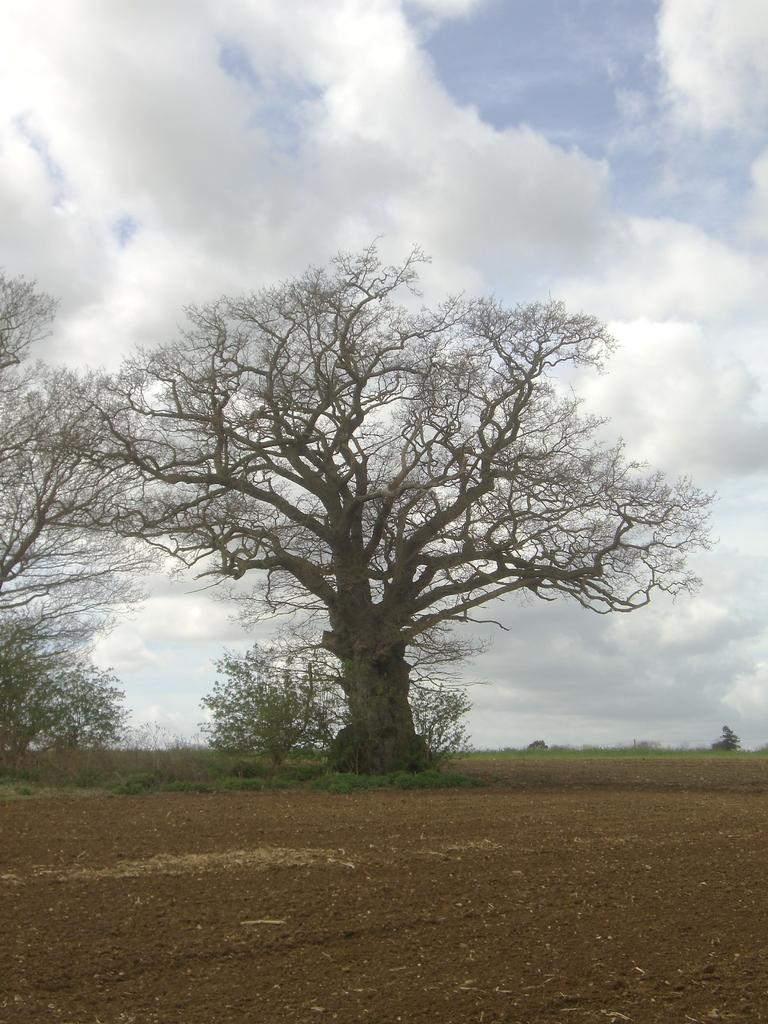What types of terrain are visible at the bottom of the image? There is sand and grass at the bottom of the image. What natural elements can be seen in the center of the image? There are trees and plants in the center of the image. What is visible at the top of the image? The sky is visible at the top of the image. How many trucks are parked in the grassy area in the image? There are no trucks present in the image; it features sand, grass, trees, plants, and sky. What type of bird can be seen flying in a flock in the image? There is no flock of birds visible in the image; it only features sand, grass, trees, plants, and sky. 